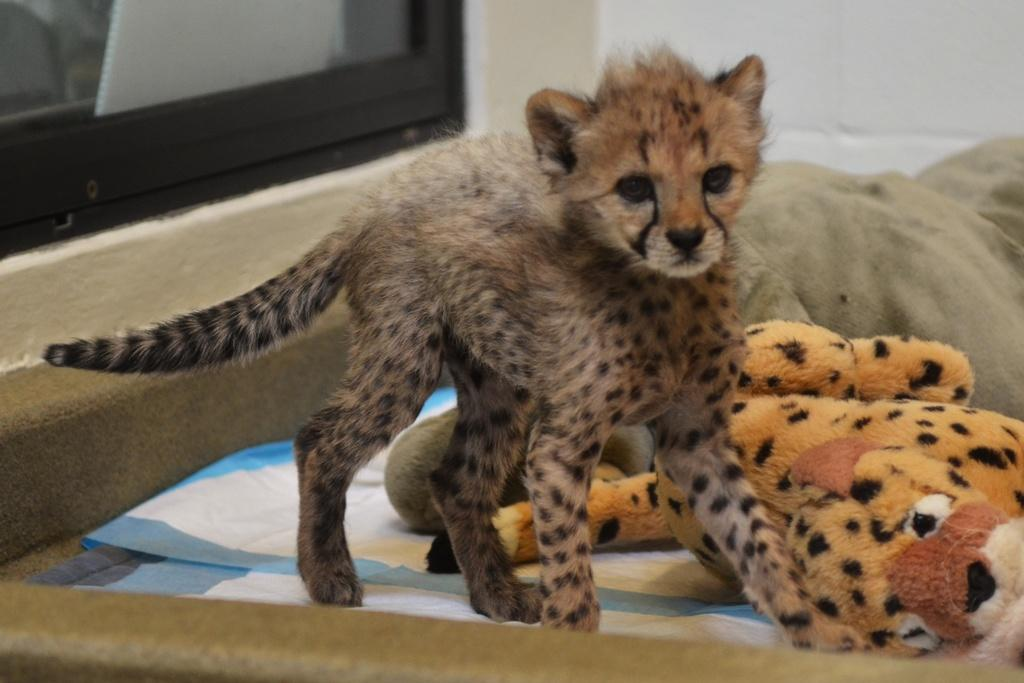What animal is standing on a cloth in the image? There is a cheetah standing on a cloth on a platform in the image. What type of object can be seen in the image besides the cheetah? There is a toy in the image. Where is the TV located in the image? The TV is in the left top corner of the image. What can be seen behind the cheetah and the toy? The wall is visible in the image. Can you describe any other objects present in the image? Other objects are present in the image, but their specific details are not mentioned in the provided facts. Is there any visible wound on the cheetah in the image? There is no mention of a wound on the cheetah in the provided facts, and therefore it cannot be determined from the image. 